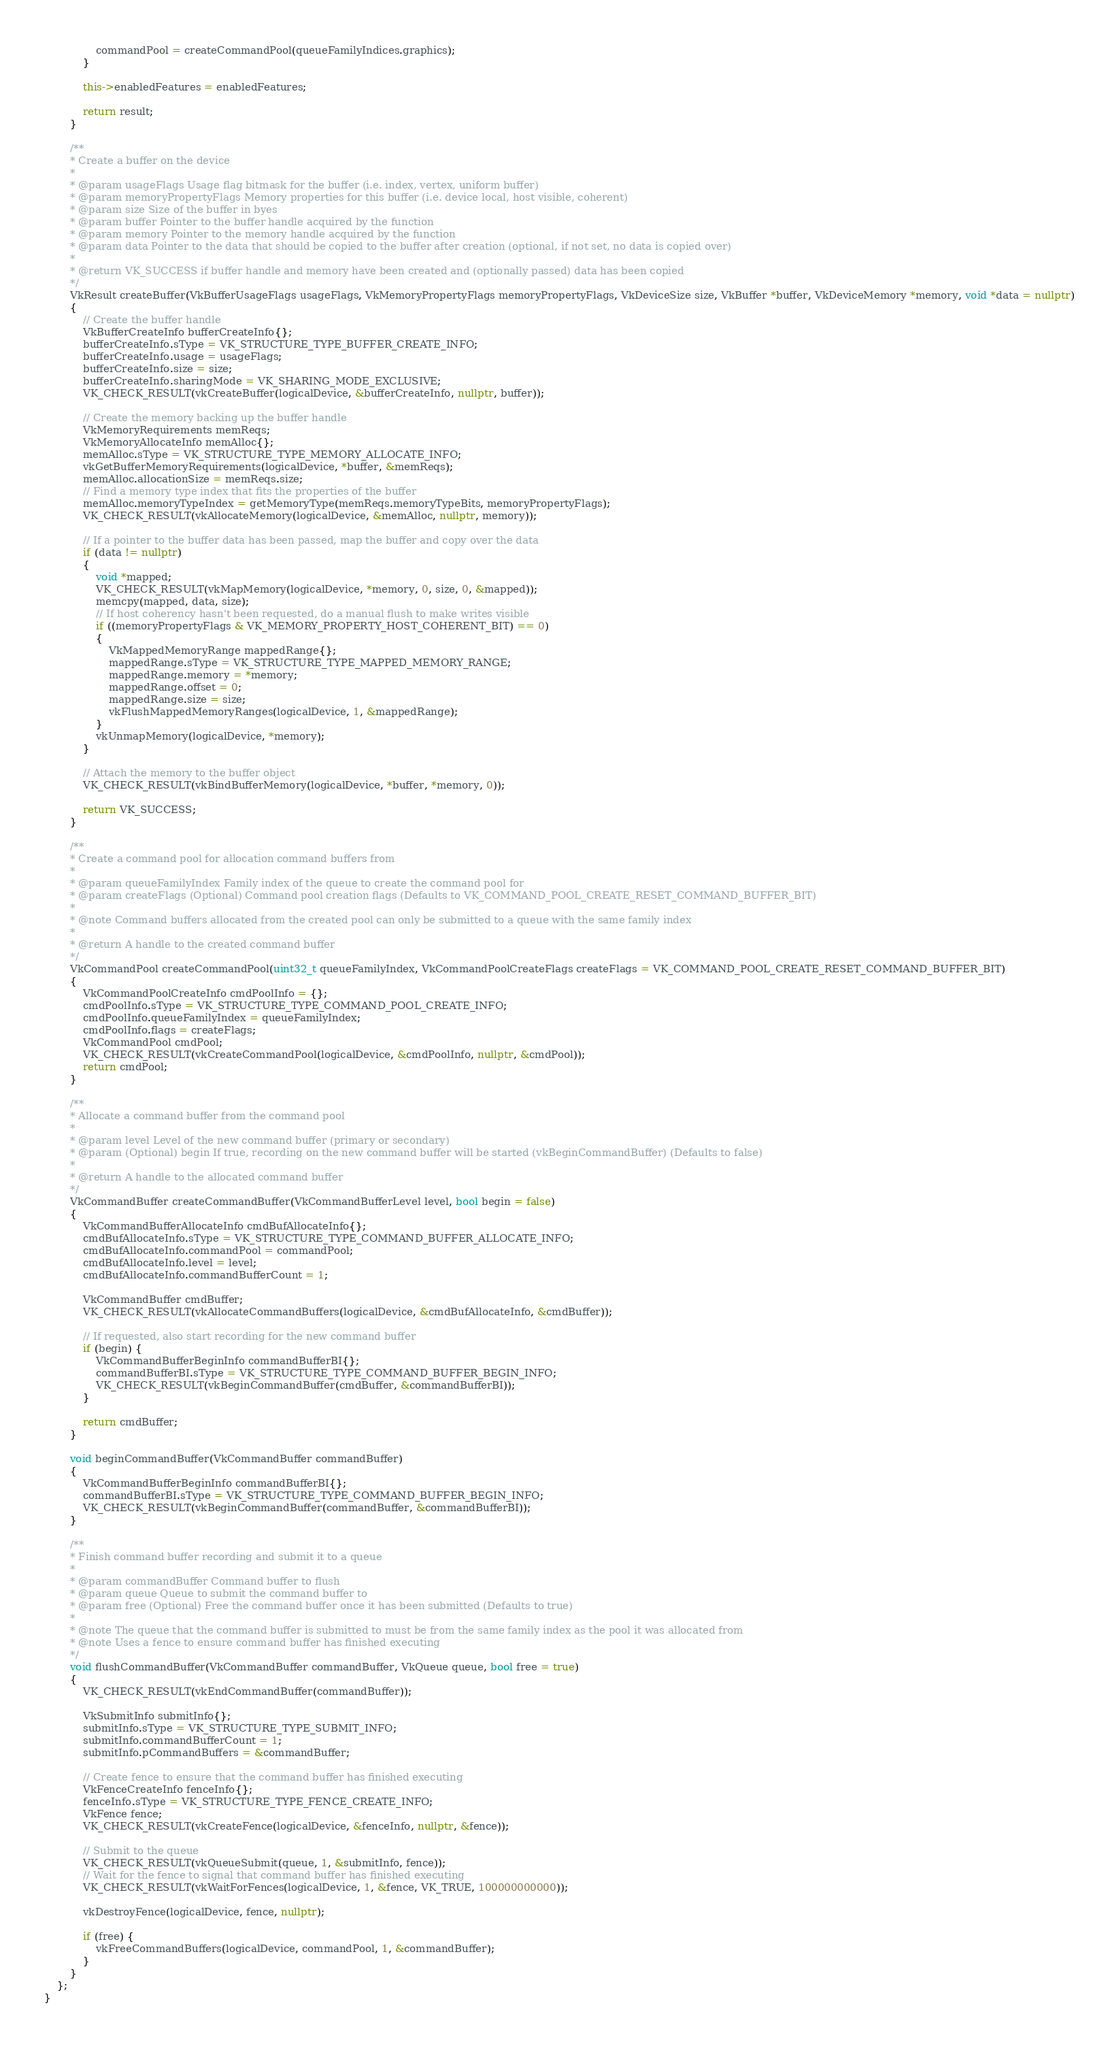<code> <loc_0><loc_0><loc_500><loc_500><_C++_>				commandPool = createCommandPool(queueFamilyIndices.graphics);
			}

			this->enabledFeatures = enabledFeatures;

			return result;
		}

		/**
		* Create a buffer on the device
		*
		* @param usageFlags Usage flag bitmask for the buffer (i.e. index, vertex, uniform buffer)
		* @param memoryPropertyFlags Memory properties for this buffer (i.e. device local, host visible, coherent)
		* @param size Size of the buffer in byes
		* @param buffer Pointer to the buffer handle acquired by the function
		* @param memory Pointer to the memory handle acquired by the function
		* @param data Pointer to the data that should be copied to the buffer after creation (optional, if not set, no data is copied over)
		*
		* @return VK_SUCCESS if buffer handle and memory have been created and (optionally passed) data has been copied
		*/
		VkResult createBuffer(VkBufferUsageFlags usageFlags, VkMemoryPropertyFlags memoryPropertyFlags, VkDeviceSize size, VkBuffer *buffer, VkDeviceMemory *memory, void *data = nullptr)
		{
			// Create the buffer handle
			VkBufferCreateInfo bufferCreateInfo{};
			bufferCreateInfo.sType = VK_STRUCTURE_TYPE_BUFFER_CREATE_INFO;
			bufferCreateInfo.usage = usageFlags;
			bufferCreateInfo.size = size;
			bufferCreateInfo.sharingMode = VK_SHARING_MODE_EXCLUSIVE;
			VK_CHECK_RESULT(vkCreateBuffer(logicalDevice, &bufferCreateInfo, nullptr, buffer));

			// Create the memory backing up the buffer handle
			VkMemoryRequirements memReqs;
			VkMemoryAllocateInfo memAlloc{};
			memAlloc.sType = VK_STRUCTURE_TYPE_MEMORY_ALLOCATE_INFO;
			vkGetBufferMemoryRequirements(logicalDevice, *buffer, &memReqs);
			memAlloc.allocationSize = memReqs.size;
			// Find a memory type index that fits the properties of the buffer
			memAlloc.memoryTypeIndex = getMemoryType(memReqs.memoryTypeBits, memoryPropertyFlags);
			VK_CHECK_RESULT(vkAllocateMemory(logicalDevice, &memAlloc, nullptr, memory));
			
			// If a pointer to the buffer data has been passed, map the buffer and copy over the data
			if (data != nullptr)
			{
				void *mapped;
				VK_CHECK_RESULT(vkMapMemory(logicalDevice, *memory, 0, size, 0, &mapped));
				memcpy(mapped, data, size);
				// If host coherency hasn't been requested, do a manual flush to make writes visible
				if ((memoryPropertyFlags & VK_MEMORY_PROPERTY_HOST_COHERENT_BIT) == 0)
				{
					VkMappedMemoryRange mappedRange{};
					mappedRange.sType = VK_STRUCTURE_TYPE_MAPPED_MEMORY_RANGE;
					mappedRange.memory = *memory;
					mappedRange.offset = 0;
					mappedRange.size = size;
					vkFlushMappedMemoryRanges(logicalDevice, 1, &mappedRange);
				}
				vkUnmapMemory(logicalDevice, *memory);
			}

			// Attach the memory to the buffer object
			VK_CHECK_RESULT(vkBindBufferMemory(logicalDevice, *buffer, *memory, 0));

			return VK_SUCCESS;
		}

		/** 
		* Create a command pool for allocation command buffers from
		* 
		* @param queueFamilyIndex Family index of the queue to create the command pool for
		* @param createFlags (Optional) Command pool creation flags (Defaults to VK_COMMAND_POOL_CREATE_RESET_COMMAND_BUFFER_BIT)
		*
		* @note Command buffers allocated from the created pool can only be submitted to a queue with the same family index
		*
		* @return A handle to the created command buffer
		*/
		VkCommandPool createCommandPool(uint32_t queueFamilyIndex, VkCommandPoolCreateFlags createFlags = VK_COMMAND_POOL_CREATE_RESET_COMMAND_BUFFER_BIT)
		{
			VkCommandPoolCreateInfo cmdPoolInfo = {};
			cmdPoolInfo.sType = VK_STRUCTURE_TYPE_COMMAND_POOL_CREATE_INFO;
			cmdPoolInfo.queueFamilyIndex = queueFamilyIndex;
			cmdPoolInfo.flags = createFlags;
			VkCommandPool cmdPool;
			VK_CHECK_RESULT(vkCreateCommandPool(logicalDevice, &cmdPoolInfo, nullptr, &cmdPool));
			return cmdPool;
		}

		/**
		* Allocate a command buffer from the command pool
		*
		* @param level Level of the new command buffer (primary or secondary)
		* @param (Optional) begin If true, recording on the new command buffer will be started (vkBeginCommandBuffer) (Defaults to false)
		*
		* @return A handle to the allocated command buffer
		*/
		VkCommandBuffer createCommandBuffer(VkCommandBufferLevel level, bool begin = false)
		{
			VkCommandBufferAllocateInfo cmdBufAllocateInfo{};
			cmdBufAllocateInfo.sType = VK_STRUCTURE_TYPE_COMMAND_BUFFER_ALLOCATE_INFO;
			cmdBufAllocateInfo.commandPool = commandPool;
			cmdBufAllocateInfo.level = level;
			cmdBufAllocateInfo.commandBufferCount = 1;

			VkCommandBuffer cmdBuffer;
			VK_CHECK_RESULT(vkAllocateCommandBuffers(logicalDevice, &cmdBufAllocateInfo, &cmdBuffer));

			// If requested, also start recording for the new command buffer
			if (begin) {
				VkCommandBufferBeginInfo commandBufferBI{};
				commandBufferBI.sType = VK_STRUCTURE_TYPE_COMMAND_BUFFER_BEGIN_INFO;
				VK_CHECK_RESULT(vkBeginCommandBuffer(cmdBuffer, &commandBufferBI));
			}

			return cmdBuffer;
		}

		void beginCommandBuffer(VkCommandBuffer commandBuffer)
		{
			VkCommandBufferBeginInfo commandBufferBI{};
			commandBufferBI.sType = VK_STRUCTURE_TYPE_COMMAND_BUFFER_BEGIN_INFO;
			VK_CHECK_RESULT(vkBeginCommandBuffer(commandBuffer, &commandBufferBI));
		}

		/**
		* Finish command buffer recording and submit it to a queue
		*
		* @param commandBuffer Command buffer to flush
		* @param queue Queue to submit the command buffer to 
		* @param free (Optional) Free the command buffer once it has been submitted (Defaults to true)
		*
		* @note The queue that the command buffer is submitted to must be from the same family index as the pool it was allocated from
		* @note Uses a fence to ensure command buffer has finished executing
		*/
		void flushCommandBuffer(VkCommandBuffer commandBuffer, VkQueue queue, bool free = true)
		{			
			VK_CHECK_RESULT(vkEndCommandBuffer(commandBuffer));

			VkSubmitInfo submitInfo{};
			submitInfo.sType = VK_STRUCTURE_TYPE_SUBMIT_INFO;
			submitInfo.commandBufferCount = 1;
			submitInfo.pCommandBuffers = &commandBuffer;

			// Create fence to ensure that the command buffer has finished executing
			VkFenceCreateInfo fenceInfo{};
			fenceInfo.sType = VK_STRUCTURE_TYPE_FENCE_CREATE_INFO;
			VkFence fence;
			VK_CHECK_RESULT(vkCreateFence(logicalDevice, &fenceInfo, nullptr, &fence));
			
			// Submit to the queue
			VK_CHECK_RESULT(vkQueueSubmit(queue, 1, &submitInfo, fence));
			// Wait for the fence to signal that command buffer has finished executing
			VK_CHECK_RESULT(vkWaitForFences(logicalDevice, 1, &fence, VK_TRUE, 100000000000));

			vkDestroyFence(logicalDevice, fence, nullptr);

			if (free) {
				vkFreeCommandBuffers(logicalDevice, commandPool, 1, &commandBuffer);
			}
		}
	};
}
</code> 